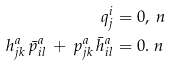Convert formula to latex. <formula><loc_0><loc_0><loc_500><loc_500>q ^ { i } _ { j } & = 0 , \ n \\ h ^ { a } _ { j k } \, \bar { p } ^ { a } _ { i l } \, + \, p ^ { a } _ { j k } \, \bar { h } ^ { a } _ { i l } & = 0 . \ n</formula> 